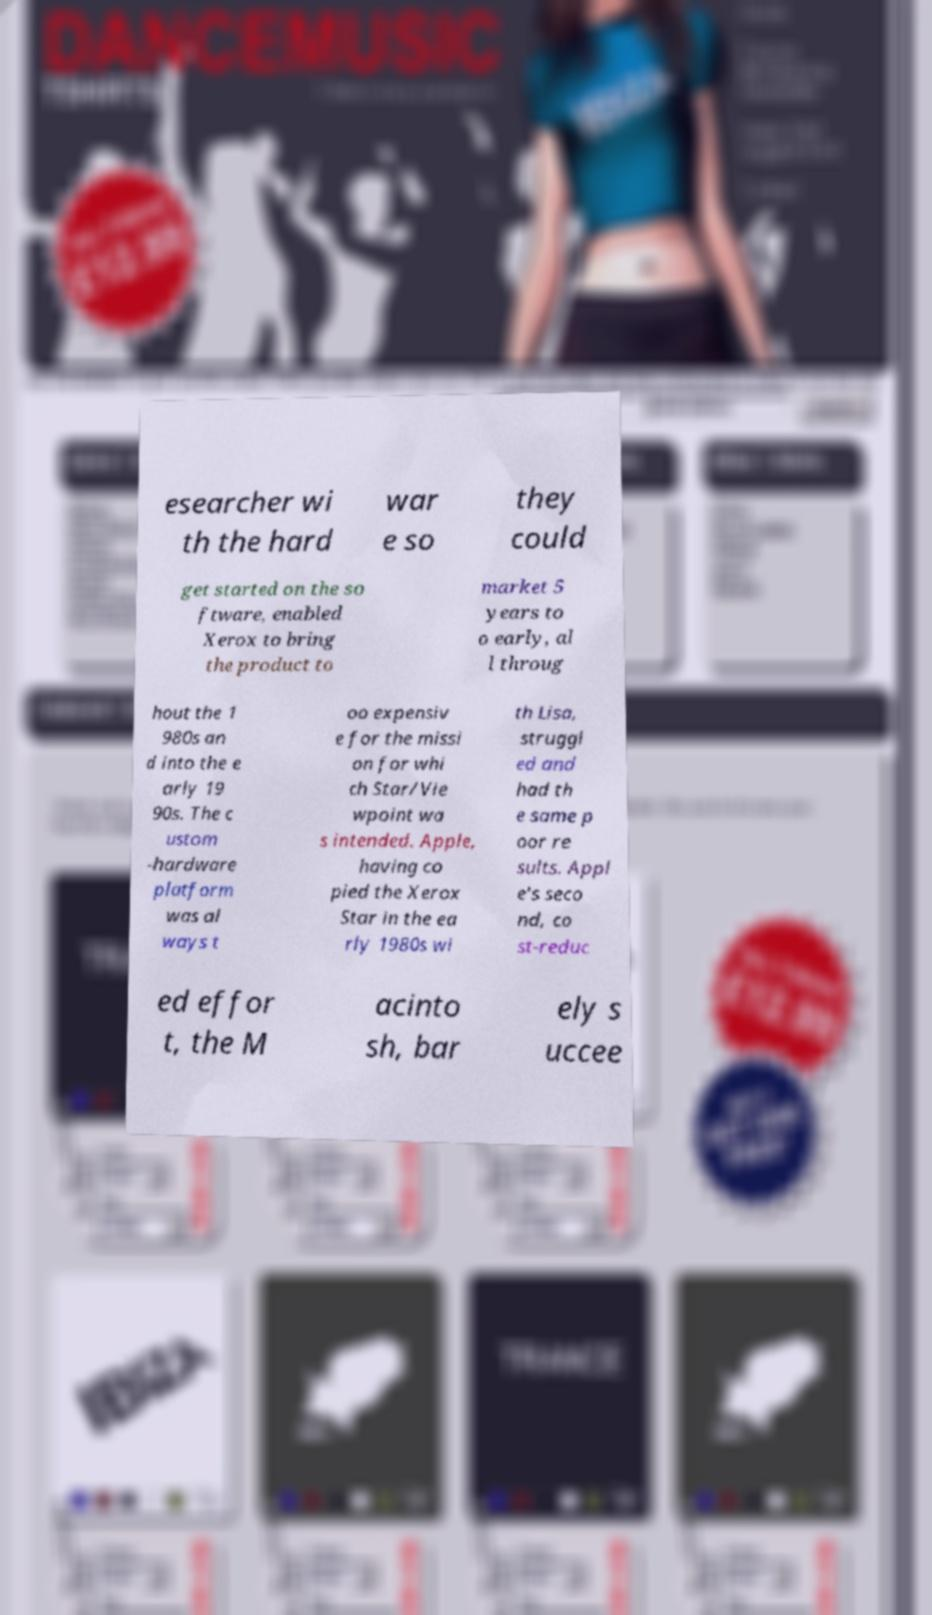Can you accurately transcribe the text from the provided image for me? esearcher wi th the hard war e so they could get started on the so ftware, enabled Xerox to bring the product to market 5 years to o early, al l throug hout the 1 980s an d into the e arly 19 90s. The c ustom -hardware platform was al ways t oo expensiv e for the missi on for whi ch Star/Vie wpoint wa s intended. Apple, having co pied the Xerox Star in the ea rly 1980s wi th Lisa, struggl ed and had th e same p oor re sults. Appl e's seco nd, co st-reduc ed effor t, the M acinto sh, bar ely s uccee 